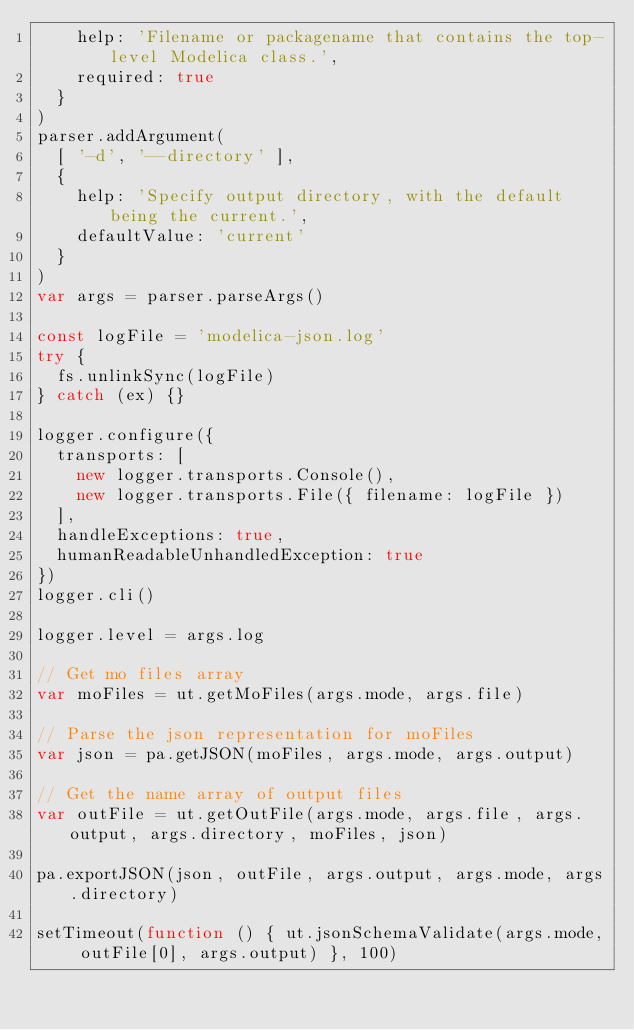Convert code to text. <code><loc_0><loc_0><loc_500><loc_500><_JavaScript_>    help: 'Filename or packagename that contains the top-level Modelica class.',
    required: true
  }
)
parser.addArgument(
  [ '-d', '--directory' ],
  {
    help: 'Specify output directory, with the default being the current.',
    defaultValue: 'current'
  }
)
var args = parser.parseArgs()

const logFile = 'modelica-json.log'
try {
  fs.unlinkSync(logFile)
} catch (ex) {}

logger.configure({
  transports: [
    new logger.transports.Console(),
    new logger.transports.File({ filename: logFile })
  ],
  handleExceptions: true,
  humanReadableUnhandledException: true
})
logger.cli()

logger.level = args.log

// Get mo files array
var moFiles = ut.getMoFiles(args.mode, args.file)

// Parse the json representation for moFiles
var json = pa.getJSON(moFiles, args.mode, args.output)

// Get the name array of output files
var outFile = ut.getOutFile(args.mode, args.file, args.output, args.directory, moFiles, json)

pa.exportJSON(json, outFile, args.output, args.mode, args.directory)

setTimeout(function () { ut.jsonSchemaValidate(args.mode, outFile[0], args.output) }, 100)
</code> 